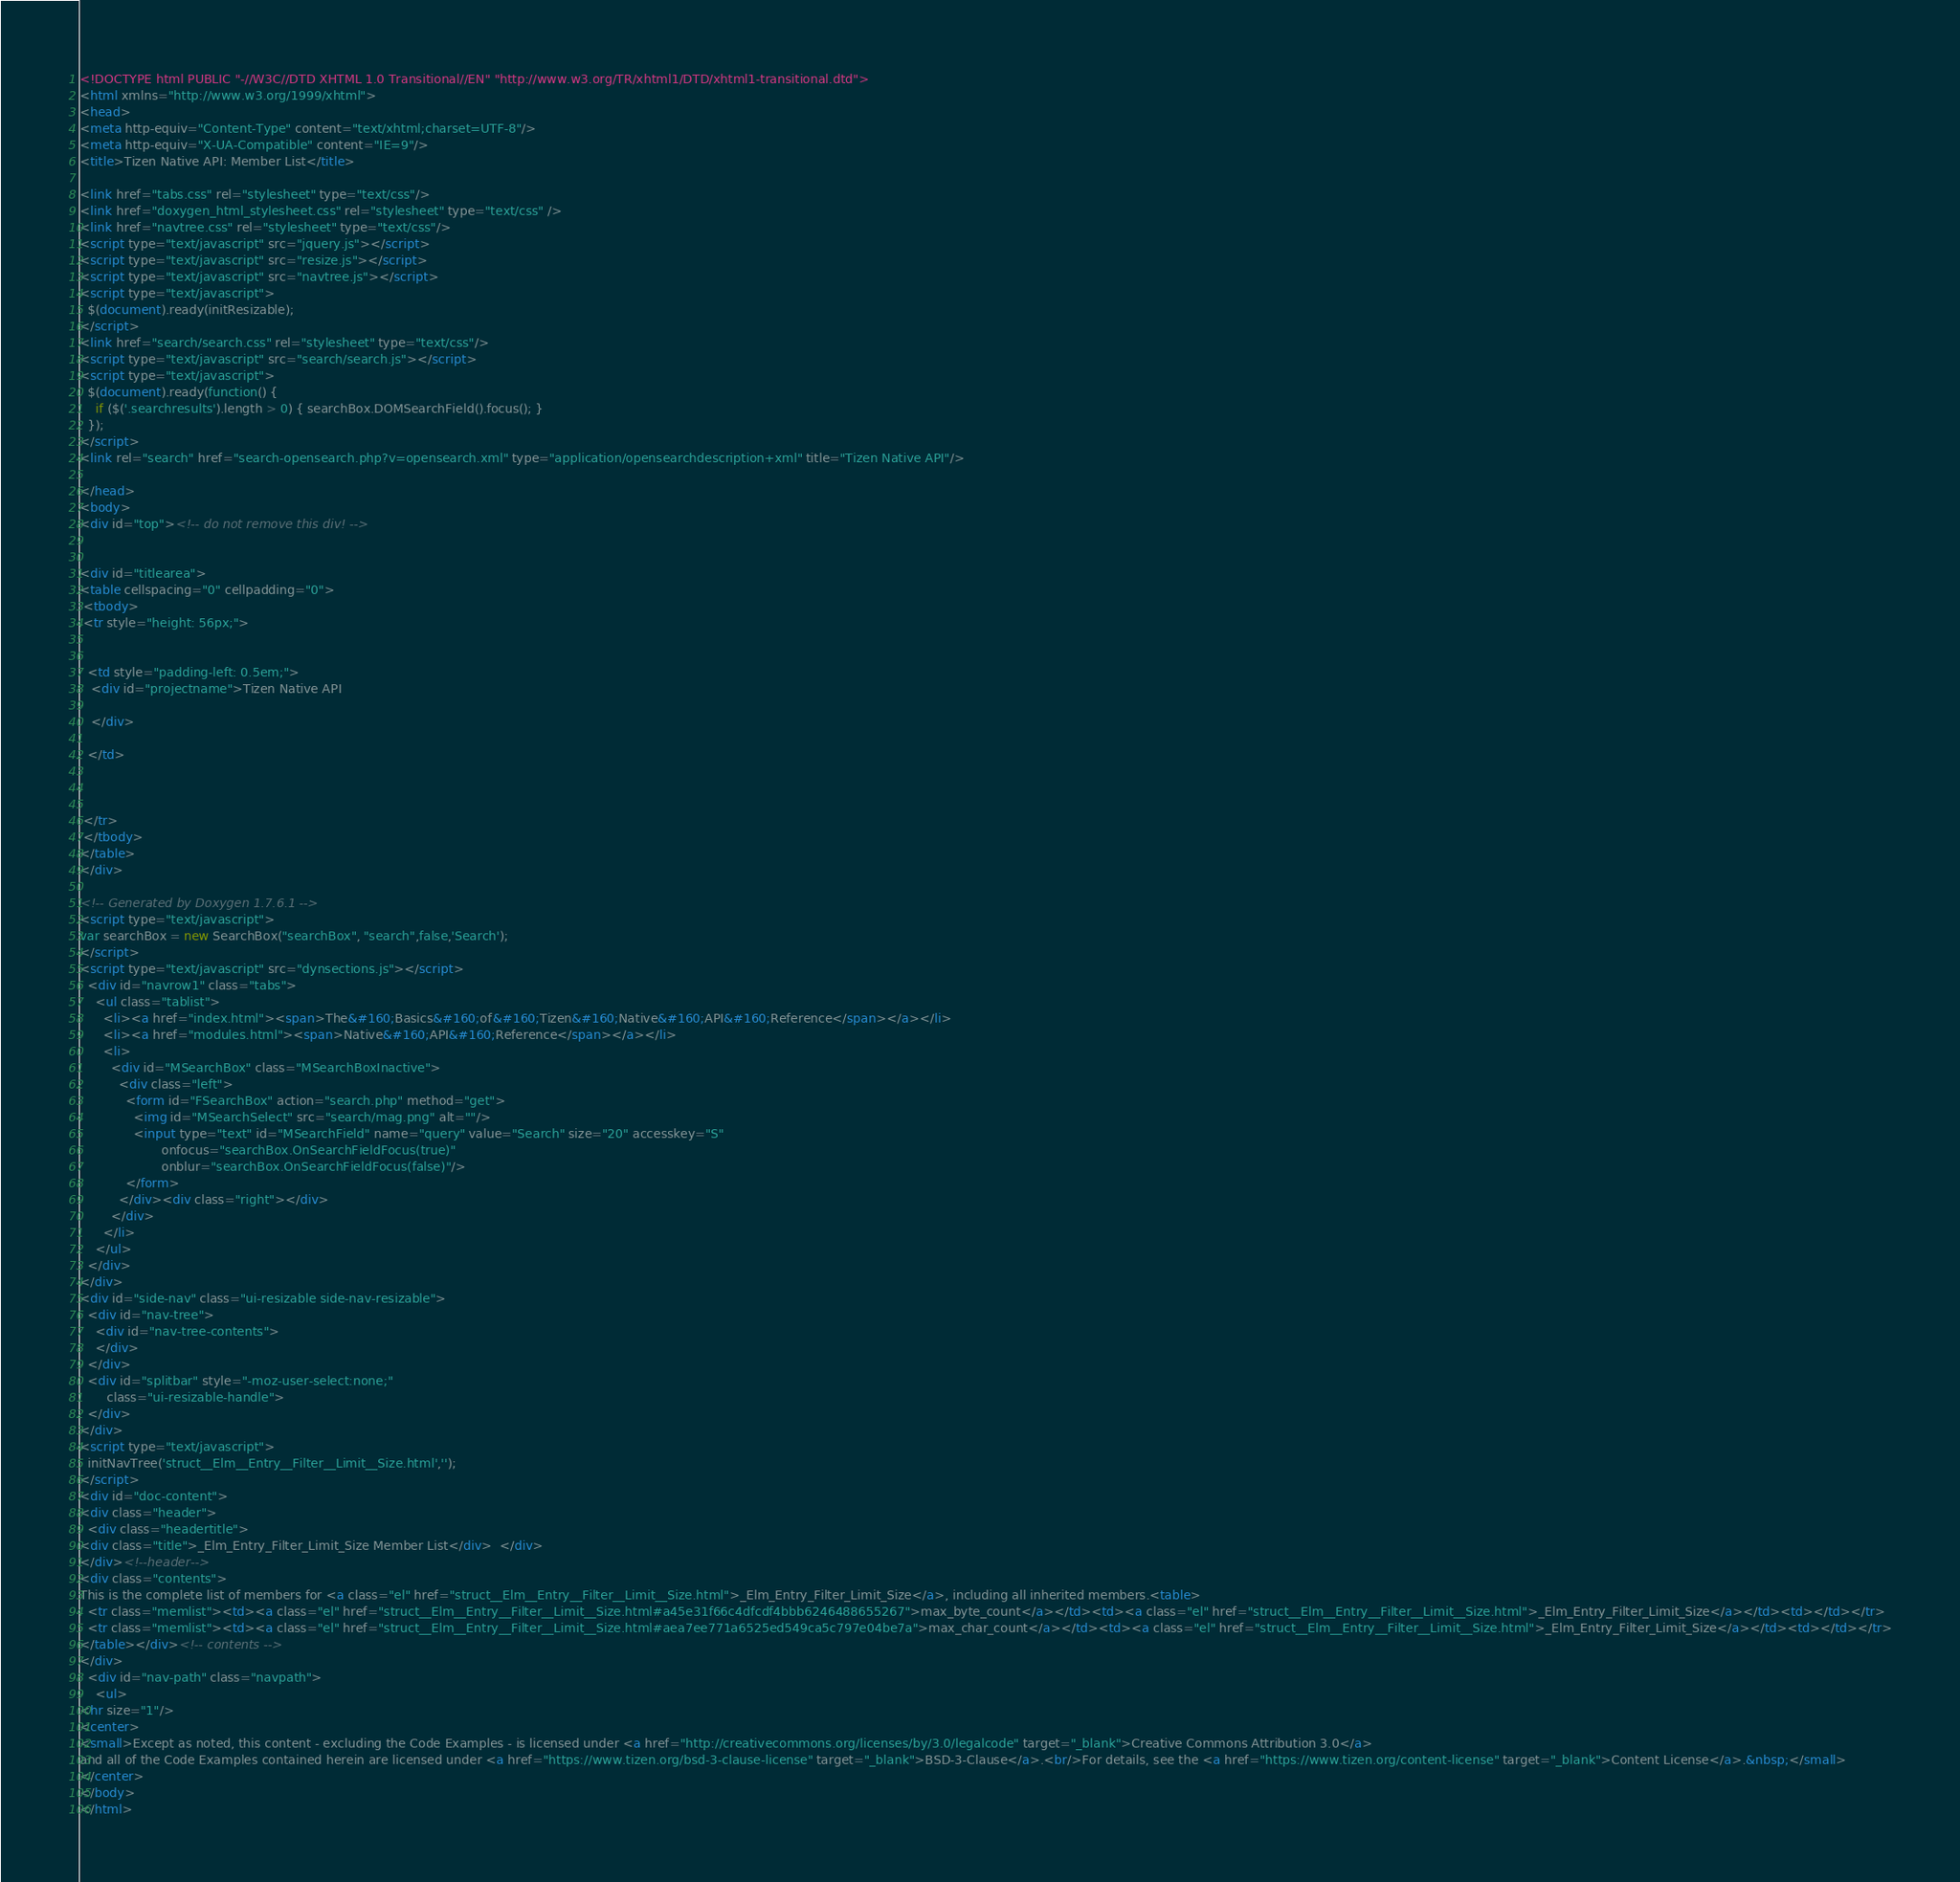Convert code to text. <code><loc_0><loc_0><loc_500><loc_500><_HTML_><!DOCTYPE html PUBLIC "-//W3C//DTD XHTML 1.0 Transitional//EN" "http://www.w3.org/TR/xhtml1/DTD/xhtml1-transitional.dtd">
<html xmlns="http://www.w3.org/1999/xhtml">
<head>
<meta http-equiv="Content-Type" content="text/xhtml;charset=UTF-8"/>
<meta http-equiv="X-UA-Compatible" content="IE=9"/>
<title>Tizen Native API: Member List</title>

<link href="tabs.css" rel="stylesheet" type="text/css"/>
<link href="doxygen_html_stylesheet.css" rel="stylesheet" type="text/css" />
<link href="navtree.css" rel="stylesheet" type="text/css"/>
<script type="text/javascript" src="jquery.js"></script>
<script type="text/javascript" src="resize.js"></script>
<script type="text/javascript" src="navtree.js"></script>
<script type="text/javascript">
  $(document).ready(initResizable);
</script>
<link href="search/search.css" rel="stylesheet" type="text/css"/>
<script type="text/javascript" src="search/search.js"></script>
<script type="text/javascript">
  $(document).ready(function() {
    if ($('.searchresults').length > 0) { searchBox.DOMSearchField().focus(); }
  });
</script>
<link rel="search" href="search-opensearch.php?v=opensearch.xml" type="application/opensearchdescription+xml" title="Tizen Native API"/>

</head>
<body>
<div id="top"><!-- do not remove this div! -->


<div id="titlearea">
<table cellspacing="0" cellpadding="0">
 <tbody>
 <tr style="height: 56px;">
  
  
  <td style="padding-left: 0.5em;">
   <div id="projectname">Tizen Native API
   
   </div>
   
  </td>
  
  
  
 </tr>
 </tbody>
</table>
</div>

<!-- Generated by Doxygen 1.7.6.1 -->
<script type="text/javascript">
var searchBox = new SearchBox("searchBox", "search",false,'Search');
</script>
<script type="text/javascript" src="dynsections.js"></script>
  <div id="navrow1" class="tabs">
    <ul class="tablist">
      <li><a href="index.html"><span>The&#160;Basics&#160;of&#160;Tizen&#160;Native&#160;API&#160;Reference</span></a></li>
      <li><a href="modules.html"><span>Native&#160;API&#160;Reference</span></a></li>
      <li>
        <div id="MSearchBox" class="MSearchBoxInactive">
          <div class="left">
            <form id="FSearchBox" action="search.php" method="get">
              <img id="MSearchSelect" src="search/mag.png" alt=""/>
              <input type="text" id="MSearchField" name="query" value="Search" size="20" accesskey="S" 
                     onfocus="searchBox.OnSearchFieldFocus(true)" 
                     onblur="searchBox.OnSearchFieldFocus(false)"/>
            </form>
          </div><div class="right"></div>
        </div>
      </li>
    </ul>
  </div>
</div>
<div id="side-nav" class="ui-resizable side-nav-resizable">
  <div id="nav-tree">
    <div id="nav-tree-contents">
    </div>
  </div>
  <div id="splitbar" style="-moz-user-select:none;" 
       class="ui-resizable-handle">
  </div>
</div>
<script type="text/javascript">
  initNavTree('struct__Elm__Entry__Filter__Limit__Size.html','');
</script>
<div id="doc-content">
<div class="header">
  <div class="headertitle">
<div class="title">_Elm_Entry_Filter_Limit_Size Member List</div>  </div>
</div><!--header-->
<div class="contents">
This is the complete list of members for <a class="el" href="struct__Elm__Entry__Filter__Limit__Size.html">_Elm_Entry_Filter_Limit_Size</a>, including all inherited members.<table>
  <tr class="memlist"><td><a class="el" href="struct__Elm__Entry__Filter__Limit__Size.html#a45e31f66c4dfcdf4bbb6246488655267">max_byte_count</a></td><td><a class="el" href="struct__Elm__Entry__Filter__Limit__Size.html">_Elm_Entry_Filter_Limit_Size</a></td><td></td></tr>
  <tr class="memlist"><td><a class="el" href="struct__Elm__Entry__Filter__Limit__Size.html#aea7ee771a6525ed549ca5c797e04be7a">max_char_count</a></td><td><a class="el" href="struct__Elm__Entry__Filter__Limit__Size.html">_Elm_Entry_Filter_Limit_Size</a></td><td></td></tr>
</table></div><!-- contents -->
</div>
  <div id="nav-path" class="navpath">
    <ul>
<hr size="1"/>
<center>
<small>Except as noted, this content - excluding the Code Examples - is licensed under <a href="http://creativecommons.org/licenses/by/3.0/legalcode" target="_blank">Creative Commons Attribution 3.0</a>
and all of the Code Examples contained herein are licensed under <a href="https://www.tizen.org/bsd-3-clause-license" target="_blank">BSD-3-Clause</a>.<br/>For details, see the <a href="https://www.tizen.org/content-license" target="_blank">Content License</a>.&nbsp;</small>
</center>
</body>
</html>
</code> 